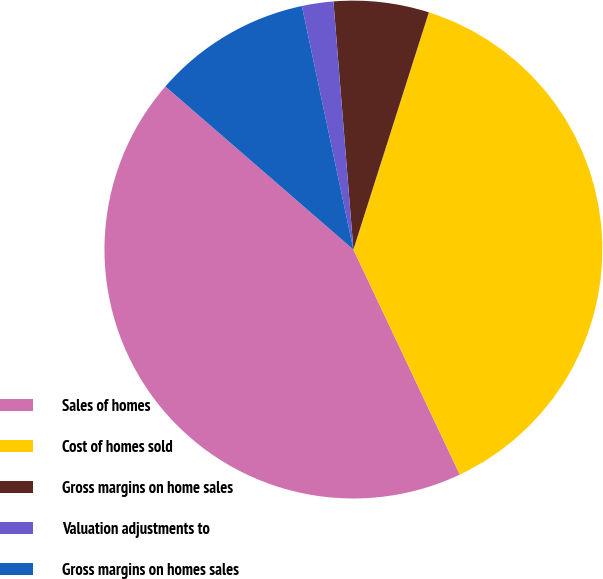<chart> <loc_0><loc_0><loc_500><loc_500><pie_chart><fcel>Sales of homes<fcel>Cost of homes sold<fcel>Gross margins on home sales<fcel>Valuation adjustments to<fcel>Gross margins on homes sales<nl><fcel>43.4%<fcel>38.07%<fcel>6.18%<fcel>2.04%<fcel>10.31%<nl></chart> 